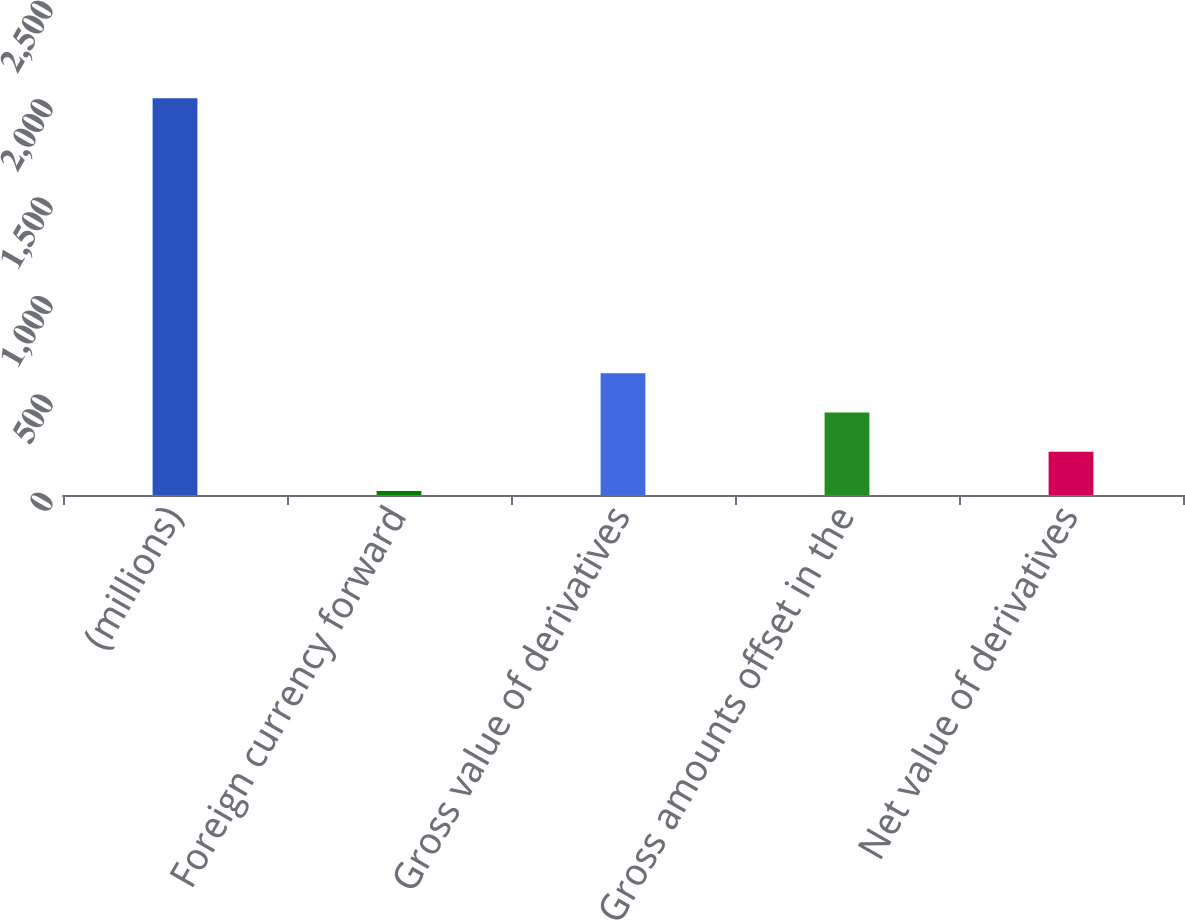Convert chart. <chart><loc_0><loc_0><loc_500><loc_500><bar_chart><fcel>(millions)<fcel>Foreign currency forward<fcel>Gross value of derivatives<fcel>Gross amounts offset in the<fcel>Net value of derivatives<nl><fcel>2016<fcel>19.8<fcel>618.66<fcel>419.04<fcel>219.42<nl></chart> 